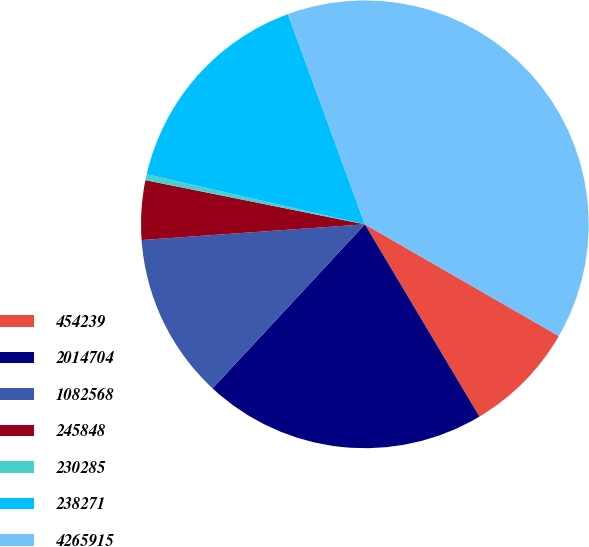Convert chart to OTSL. <chart><loc_0><loc_0><loc_500><loc_500><pie_chart><fcel>454239<fcel>2014704<fcel>1082568<fcel>245848<fcel>230285<fcel>238271<fcel>4265915<nl><fcel>8.13%<fcel>20.46%<fcel>11.97%<fcel>4.28%<fcel>0.43%<fcel>15.82%<fcel>38.9%<nl></chart> 